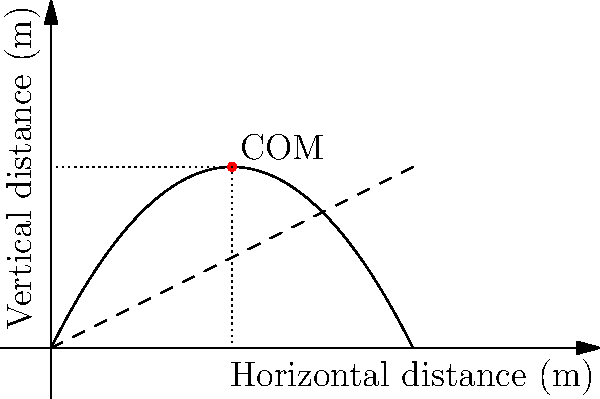During a snatch lift, a weightlifter's center of mass (COM) follows a parabolic trajectory. The graph shows the path of the COM, where the solid curve represents the actual trajectory and the dashed line represents the idealized straight path. If the maximum height reached by the COM is 2 meters at a horizontal distance of 5 meters from the starting position, what is the angle (in degrees) between the actual trajectory and the idealized straight path at the point of maximum height? To solve this problem, we need to follow these steps:

1) The point of maximum height occurs at (5m, 2m) on the graph.

2) At this point, we need to find:
   a) The slope of the actual trajectory (tangent to the parabola)
   b) The slope of the idealized straight path

3) The slope of the idealized straight path is easy to calculate:
   $m_{ideal} = \frac{2m}{5m} = 0.4$

4) For the actual trajectory, we need to find the derivative of the parabolic function at x = 5m.
   The general form of a parabola is $y = ax^2 + bx + c$
   Its derivative is $y' = 2ax + b$

5) We can determine 'a' from the given information:
   $2 = a(5^2) + b(5) + c$
   $0 = a(10^2) + b(10) + c$ (assuming the parabola reaches ground level at 10m)

   Subtracting these equations:
   $2 = -75a - 5b$
   $a = -\frac{2}{75} + \frac{b}{15}$

6) Substituting this back into the original equation:
   $2 = 25(-\frac{2}{75} + \frac{b}{15}) + 5b + c$
   $2 = -\frac{10}{3} + \frac{25b}{15} + 5b + c$
   $\frac{16}{3} = \frac{100b}{15} + c$

7) The derivative at x = 5 should be zero (point of maximum height):
   $0 = 2a(5) + b$
   $0 = 2(-\frac{2}{75} + \frac{b}{15})(5) + b$
   $0 = -\frac{4}{15} + \frac{b}{3} + b$
   $\frac{4}{15} = \frac{4b}{3}$
   $b = 0.3$

8) Now we can find the slope of the actual trajectory just before and after the maximum point:
   $y' = 2ax + b = 2(-0.0267 + 0.02)(5) + 0.3 = -0.0667 + 0.3 = 0.2333$

9) The angle between the two paths is the difference between their slopes:
   $\theta = \arctan(0.4) - \arctan(0.2333) = 21.8° - 13.1° = 8.7°$

Therefore, the angle between the actual trajectory and the idealized straight path at the point of maximum height is approximately 8.7°.
Answer: 8.7° 